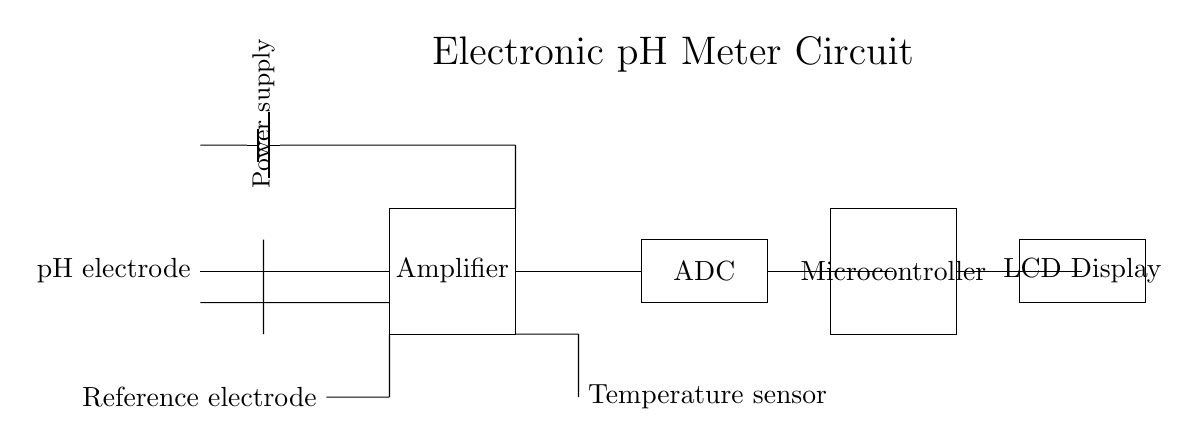What is the component that measures pH? The pH electrode is directly connected to the circuit and is responsible for measuring the pH level of the solution.
Answer: pH electrode What type of output does the circuit provide? The output from the circuit comes from the ADC, which converts the analog signal from the amplifier into a digital signal for further processing.
Answer: ADC How is temperature compensation achieved in the circuit? The temperature sensor, represented as a thermistor, provides temperature data to the system to compensate for temperature variations that affect pH readings.
Answer: Temperature sensor What is the role of the amplifier in this circuit? The amplifier increases the strength of the weak signal from the pH electrode to a level that can be processed by the ADC and microcontroller.
Answer: Amplifier What is the component used for displaying the results? The LCD Display is used to show the measured pH values as well as any other relevant information processed by the microcontroller.
Answer: LCD Display Which component supplies power to the circuit? The battery indicated in the circuit provides the required electrical energy to all components, allowing the circuit to function effectively.
Answer: Power supply 